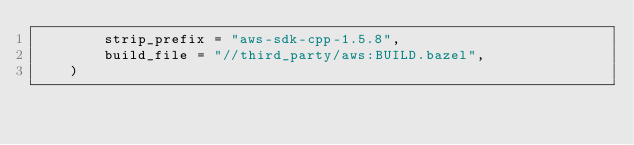Convert code to text. <code><loc_0><loc_0><loc_500><loc_500><_Python_>        strip_prefix = "aws-sdk-cpp-1.5.8",
        build_file = "//third_party/aws:BUILD.bazel",
    )
</code> 